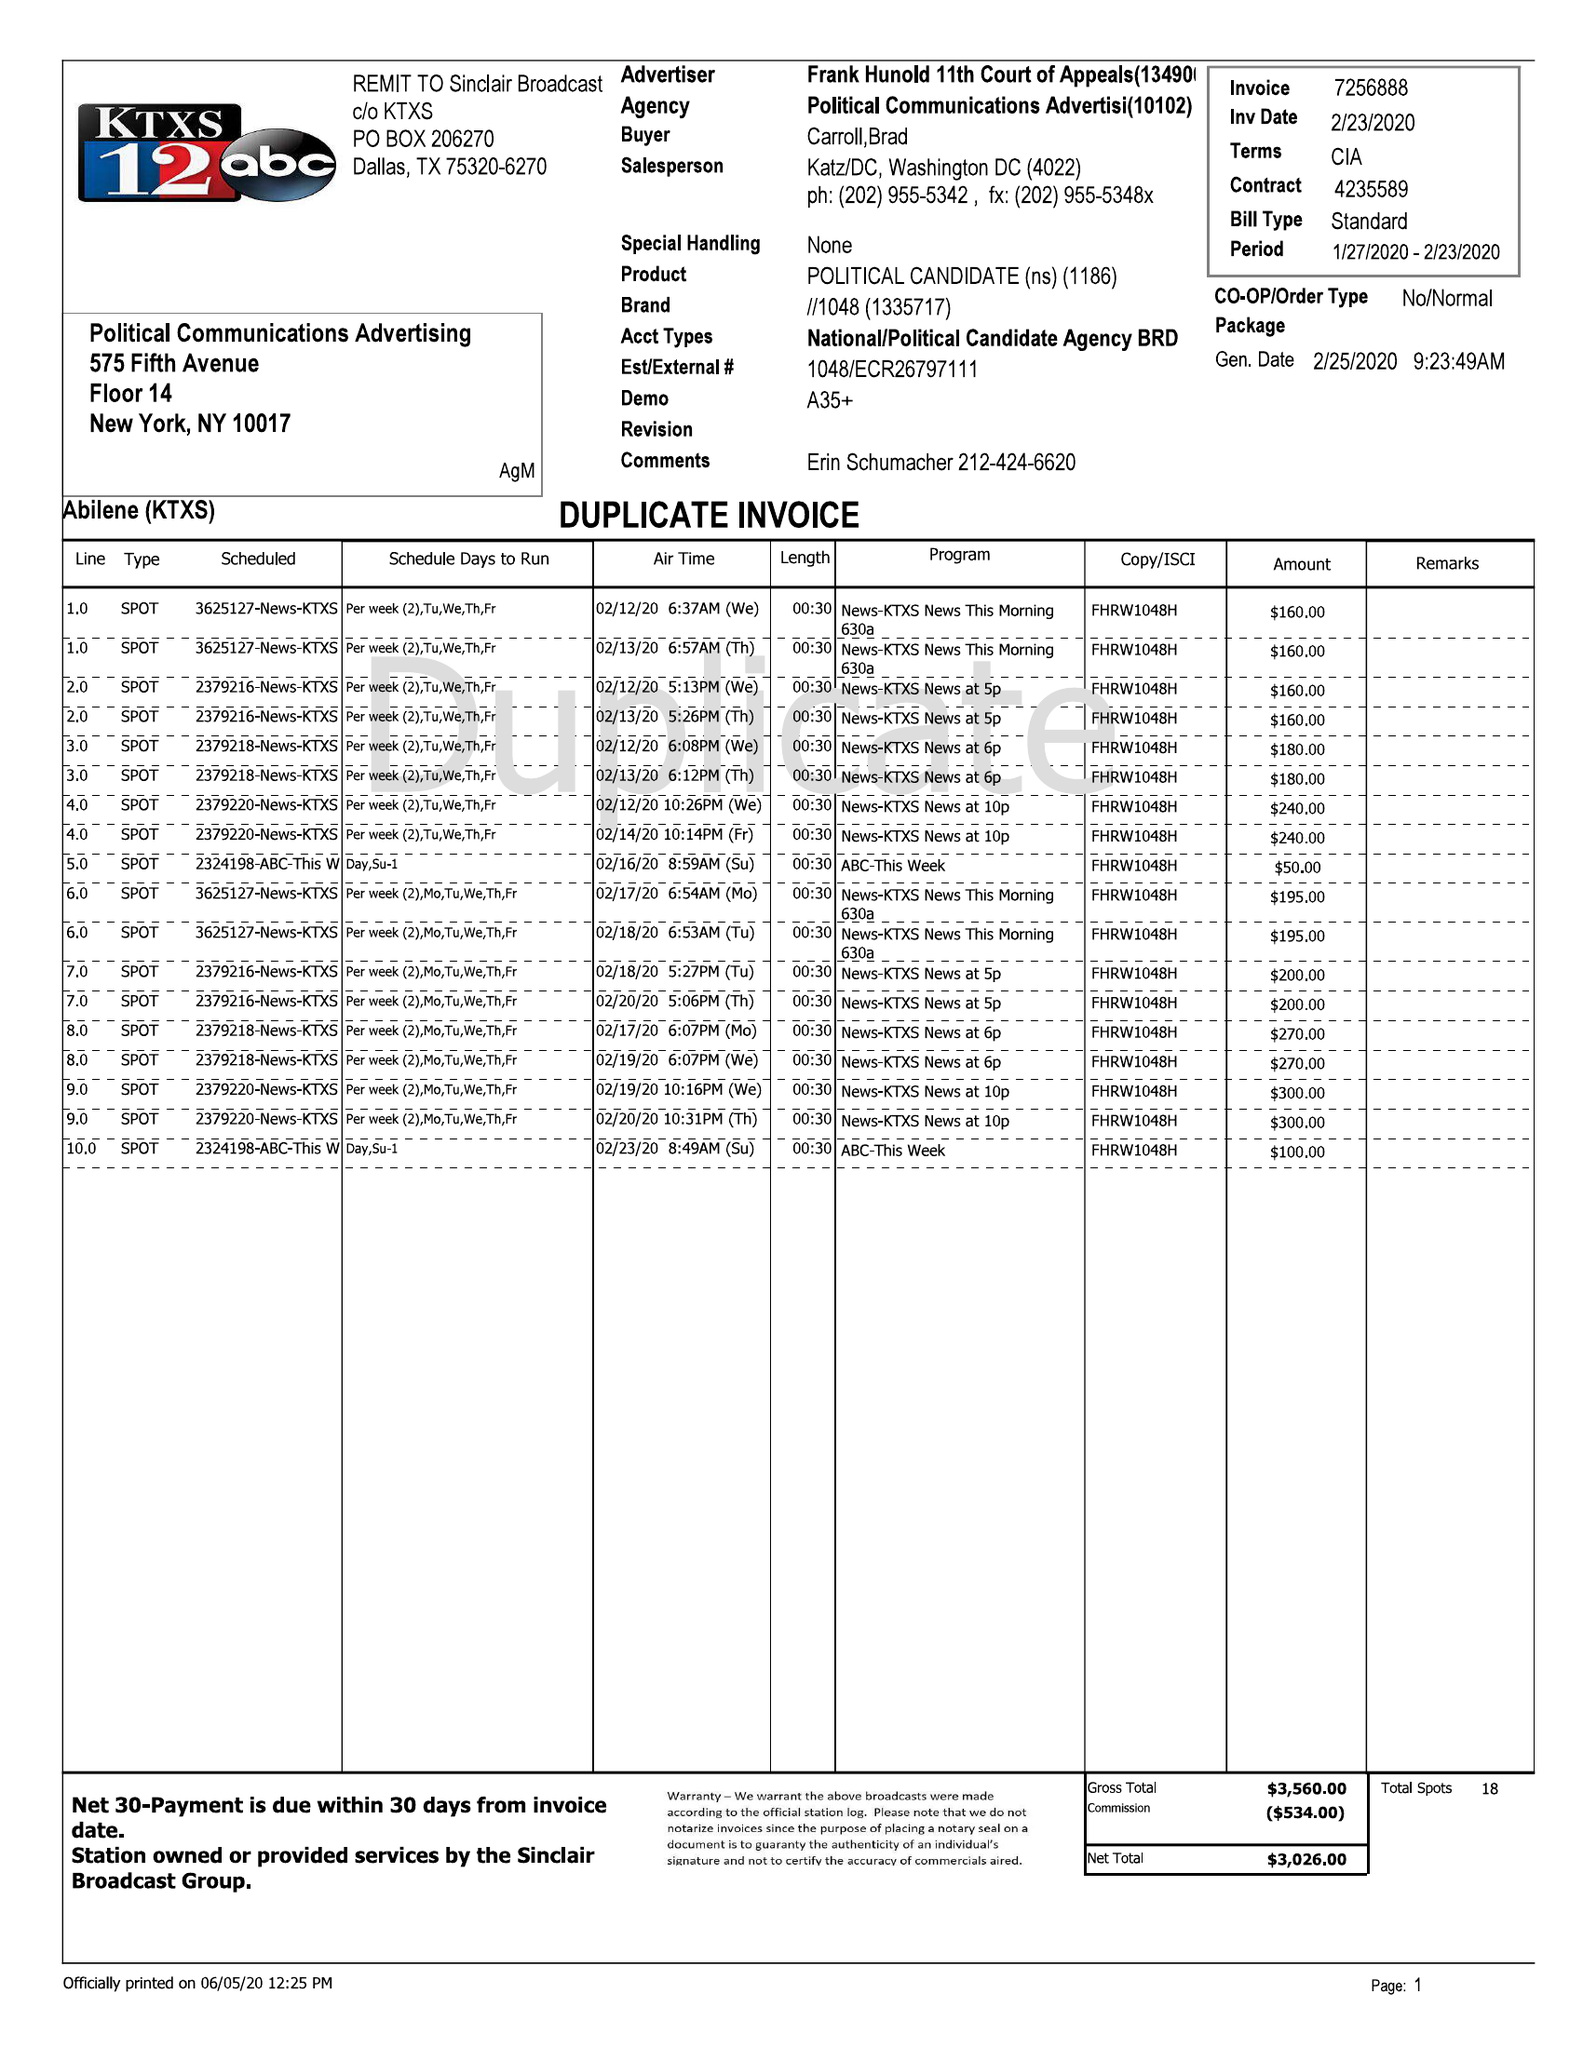What is the value for the contract_num?
Answer the question using a single word or phrase. 7256888 